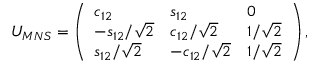Convert formula to latex. <formula><loc_0><loc_0><loc_500><loc_500>U _ { M N S } = \left ( \begin{array} { l l l } { { c _ { 1 2 } } } & { { s _ { 1 2 } } } & { 0 } \\ { { - s _ { 1 2 } / \sqrt { 2 } } } & { { c _ { 1 2 } / \sqrt { 2 } } } & { { 1 / \sqrt { 2 } } } \\ { { s _ { 1 2 } / \sqrt { 2 } } } & { { - c _ { 1 2 } / \sqrt { 2 } } } & { { 1 / \sqrt { 2 } } } \end{array} \right ) ,</formula> 